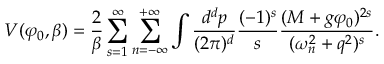<formula> <loc_0><loc_0><loc_500><loc_500>V ( \varphi _ { 0 } , \beta ) = \frac { 2 } { \beta } \sum _ { s = 1 } ^ { \infty } \sum _ { n = - \infty } ^ { + \infty } \int \frac { d ^ { d } p } { ( 2 \pi ) ^ { d } } \frac { ( - 1 ) ^ { s } } { s } \frac { ( M + g \varphi _ { 0 } ) ^ { 2 s } } { ( \omega _ { n } ^ { 2 } + q ^ { 2 } ) ^ { s } } .</formula> 